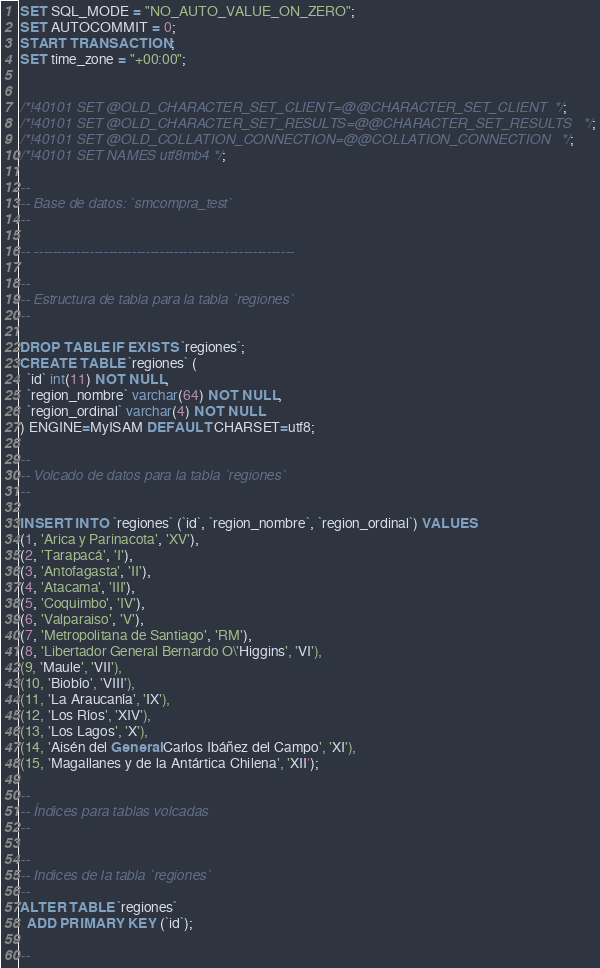<code> <loc_0><loc_0><loc_500><loc_500><_SQL_>
SET SQL_MODE = "NO_AUTO_VALUE_ON_ZERO";
SET AUTOCOMMIT = 0;
START TRANSACTION;
SET time_zone = "+00:00";


/*!40101 SET @OLD_CHARACTER_SET_CLIENT=@@CHARACTER_SET_CLIENT */;
/*!40101 SET @OLD_CHARACTER_SET_RESULTS=@@CHARACTER_SET_RESULTS */;
/*!40101 SET @OLD_COLLATION_CONNECTION=@@COLLATION_CONNECTION */;
/*!40101 SET NAMES utf8mb4 */;

--
-- Base de datos: `smcompra_test`
--

-- --------------------------------------------------------

--
-- Estructura de tabla para la tabla `regiones`
--

DROP TABLE IF EXISTS `regiones`;
CREATE TABLE `regiones` (
  `id` int(11) NOT NULL,
  `region_nombre` varchar(64) NOT NULL,
  `region_ordinal` varchar(4) NOT NULL
) ENGINE=MyISAM DEFAULT CHARSET=utf8;

--
-- Volcado de datos para la tabla `regiones`
--

INSERT INTO `regiones` (`id`, `region_nombre`, `region_ordinal`) VALUES
(1, 'Arica y Parinacota', 'XV'),
(2, 'Tarapacá', 'I'),
(3, 'Antofagasta', 'II'),
(4, 'Atacama', 'III'),
(5, 'Coquimbo', 'IV'),
(6, 'Valparaiso', 'V'),
(7, 'Metropolitana de Santiago', 'RM'),
(8, 'Libertador General Bernardo O\'Higgins', 'VI'),
(9, 'Maule', 'VII'),
(10, 'Biobío', 'VIII'),
(11, 'La Araucanía', 'IX'),
(12, 'Los Ríos', 'XIV'),
(13, 'Los Lagos', 'X'),
(14, 'Aisén del General Carlos Ibáñez del Campo', 'XI'),
(15, 'Magallanes y de la Antártica Chilena', 'XII');

--
-- Índices para tablas volcadas
--

--
-- Indices de la tabla `regiones`
--
ALTER TABLE `regiones`
  ADD PRIMARY KEY (`id`);

--</code> 